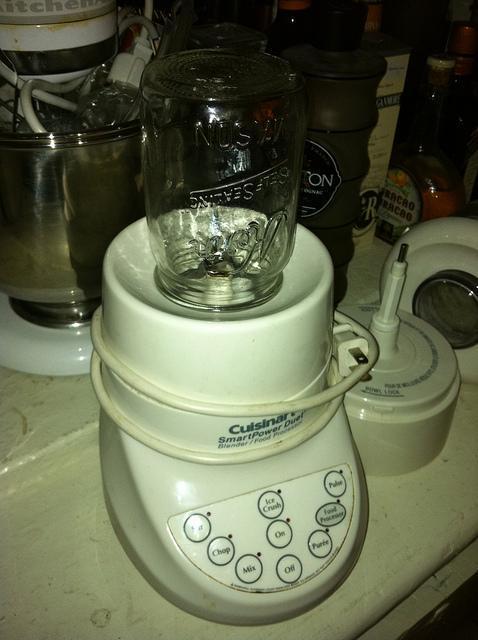How many people are wearing glasses?
Give a very brief answer. 0. 